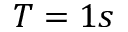<formula> <loc_0><loc_0><loc_500><loc_500>T = 1 s</formula> 